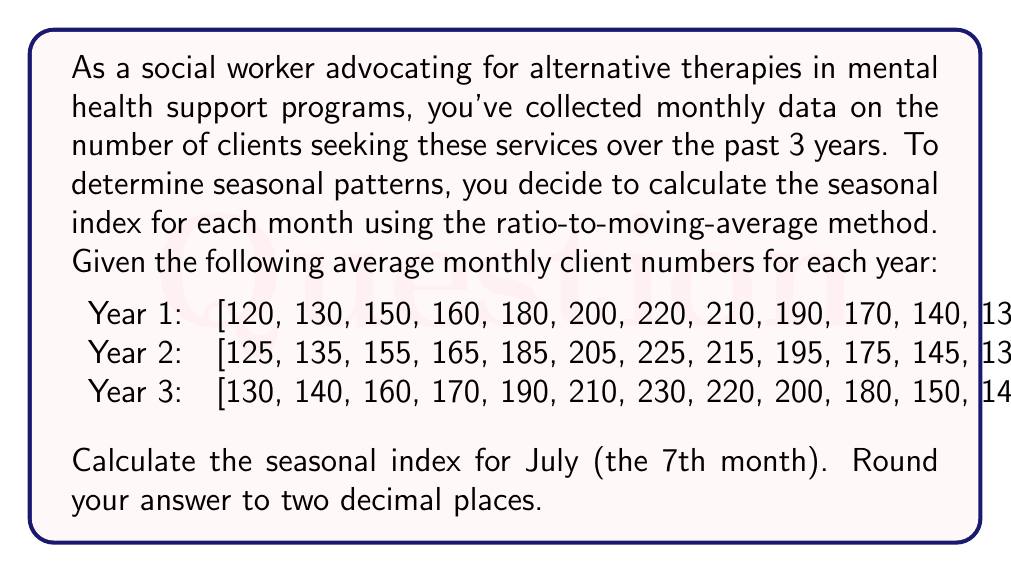Can you solve this math problem? To calculate the seasonal index for July using the ratio-to-moving-average method, we'll follow these steps:

1) Calculate the 12-month moving average:
   For each year, we'll calculate the moving average centered on July.
   
   Year 1: $\frac{150 + 160 + ... + 130 + 120 + 130}{12} = 166.67$
   Year 2: $\frac{155 + 165 + ... + 135 + 125 + 135}{12} = 171.67$
   Year 3: $\frac{160 + 170 + ... + 140 + 130 + 140}{12} = 176.67$

2) Calculate the centered moving average:
   For each year, we'll average two consecutive 12-month moving averages.
   
   Year 1: $\frac{166.67 + 171.67}{2} = 169.17$
   Year 2: $\frac{171.67 + 176.67}{2} = 174.17$

3) Calculate the specific seasonal ratio for July in each year:
   Divide the actual July value by the centered moving average.
   
   Year 1: $\frac{220}{169.17} = 1.3005$
   Year 2: $\frac{225}{174.17} = 1.2918$
   Year 3: $\frac{230}{174.17} = 1.3206$ (using Year 2's centered moving average)

4) Calculate the average seasonal ratio for July:
   $\frac{1.3005 + 1.2918 + 1.3206}{3} = 1.3043$

5) Convert to percentage:
   $1.3043 \times 100 = 130.43\%$

Therefore, the seasonal index for July is 130.43%.
Answer: 130.43 